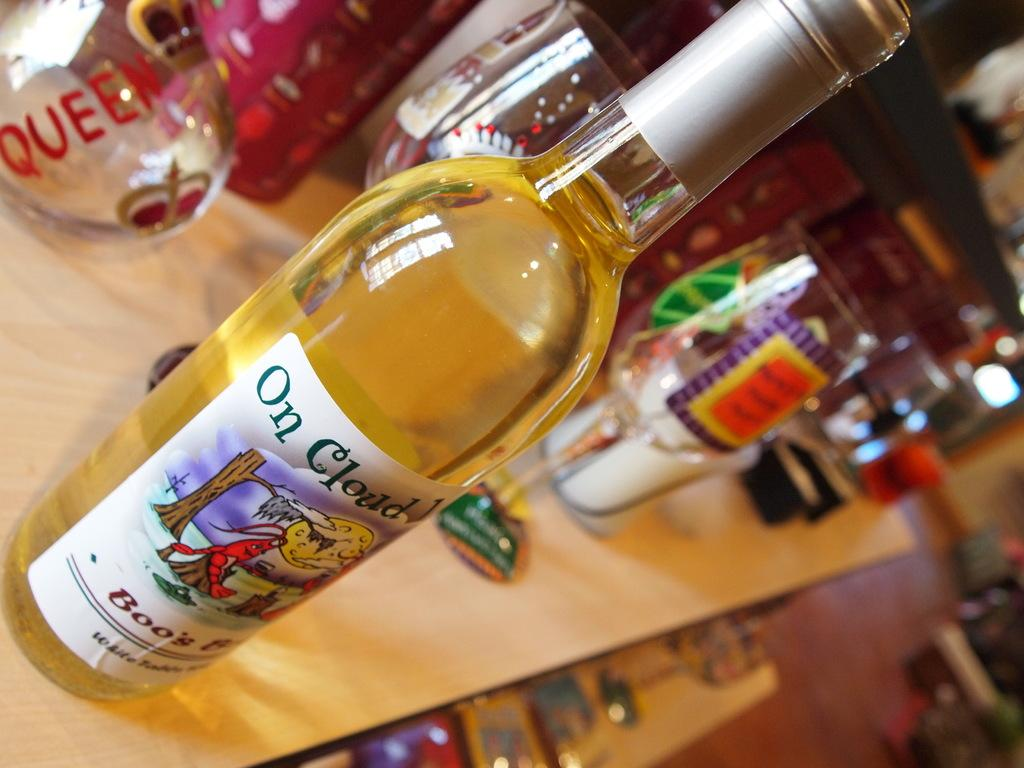<image>
Write a terse but informative summary of the picture. The label of a beer bottle makes reference to being on a cloud. 